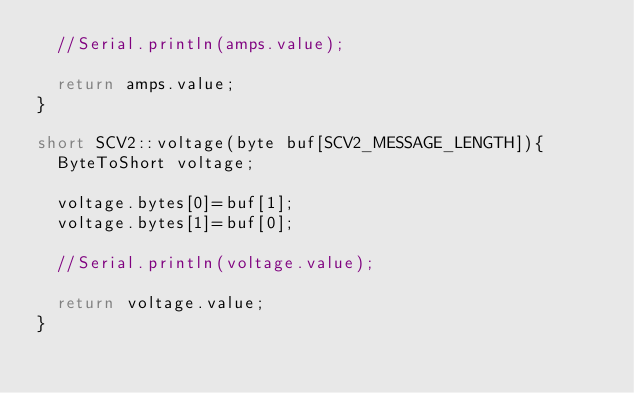Convert code to text. <code><loc_0><loc_0><loc_500><loc_500><_C++_>  //Serial.println(amps.value);

  return amps.value;
}

short SCV2::voltage(byte buf[SCV2_MESSAGE_LENGTH]){
  ByteToShort voltage;

  voltage.bytes[0]=buf[1];
  voltage.bytes[1]=buf[0];

  //Serial.println(voltage.value);

  return voltage.value;
}
</code> 